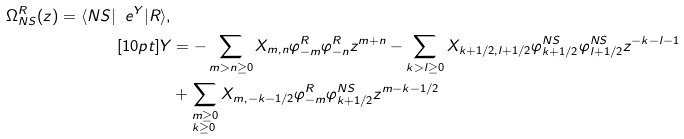<formula> <loc_0><loc_0><loc_500><loc_500>\Omega _ { N S } ^ { R } ( z ) = \langle N S | \ e ^ { Y } | R \rangle , \\ [ 1 0 p t ] Y & = - \sum _ { m > n \geq 0 } X _ { m , n } \varphi _ { - m } ^ { R } \varphi _ { - n } ^ { R } z ^ { m + n } - \sum _ { k > l \geq 0 } X _ { k + 1 / 2 , l + 1 / 2 } \varphi _ { k + 1 / 2 } ^ { N S } \varphi _ { l + 1 / 2 } ^ { N S } z ^ { - k - l - 1 } \\ & + \sum _ { \begin{subarray} { c } m \geq 0 \\ k \geq 0 \end{subarray} } X _ { m , - k - 1 / 2 } \varphi _ { - m } ^ { R } \varphi _ { k + 1 / 2 } ^ { N S } z ^ { m - k - 1 / 2 }</formula> 